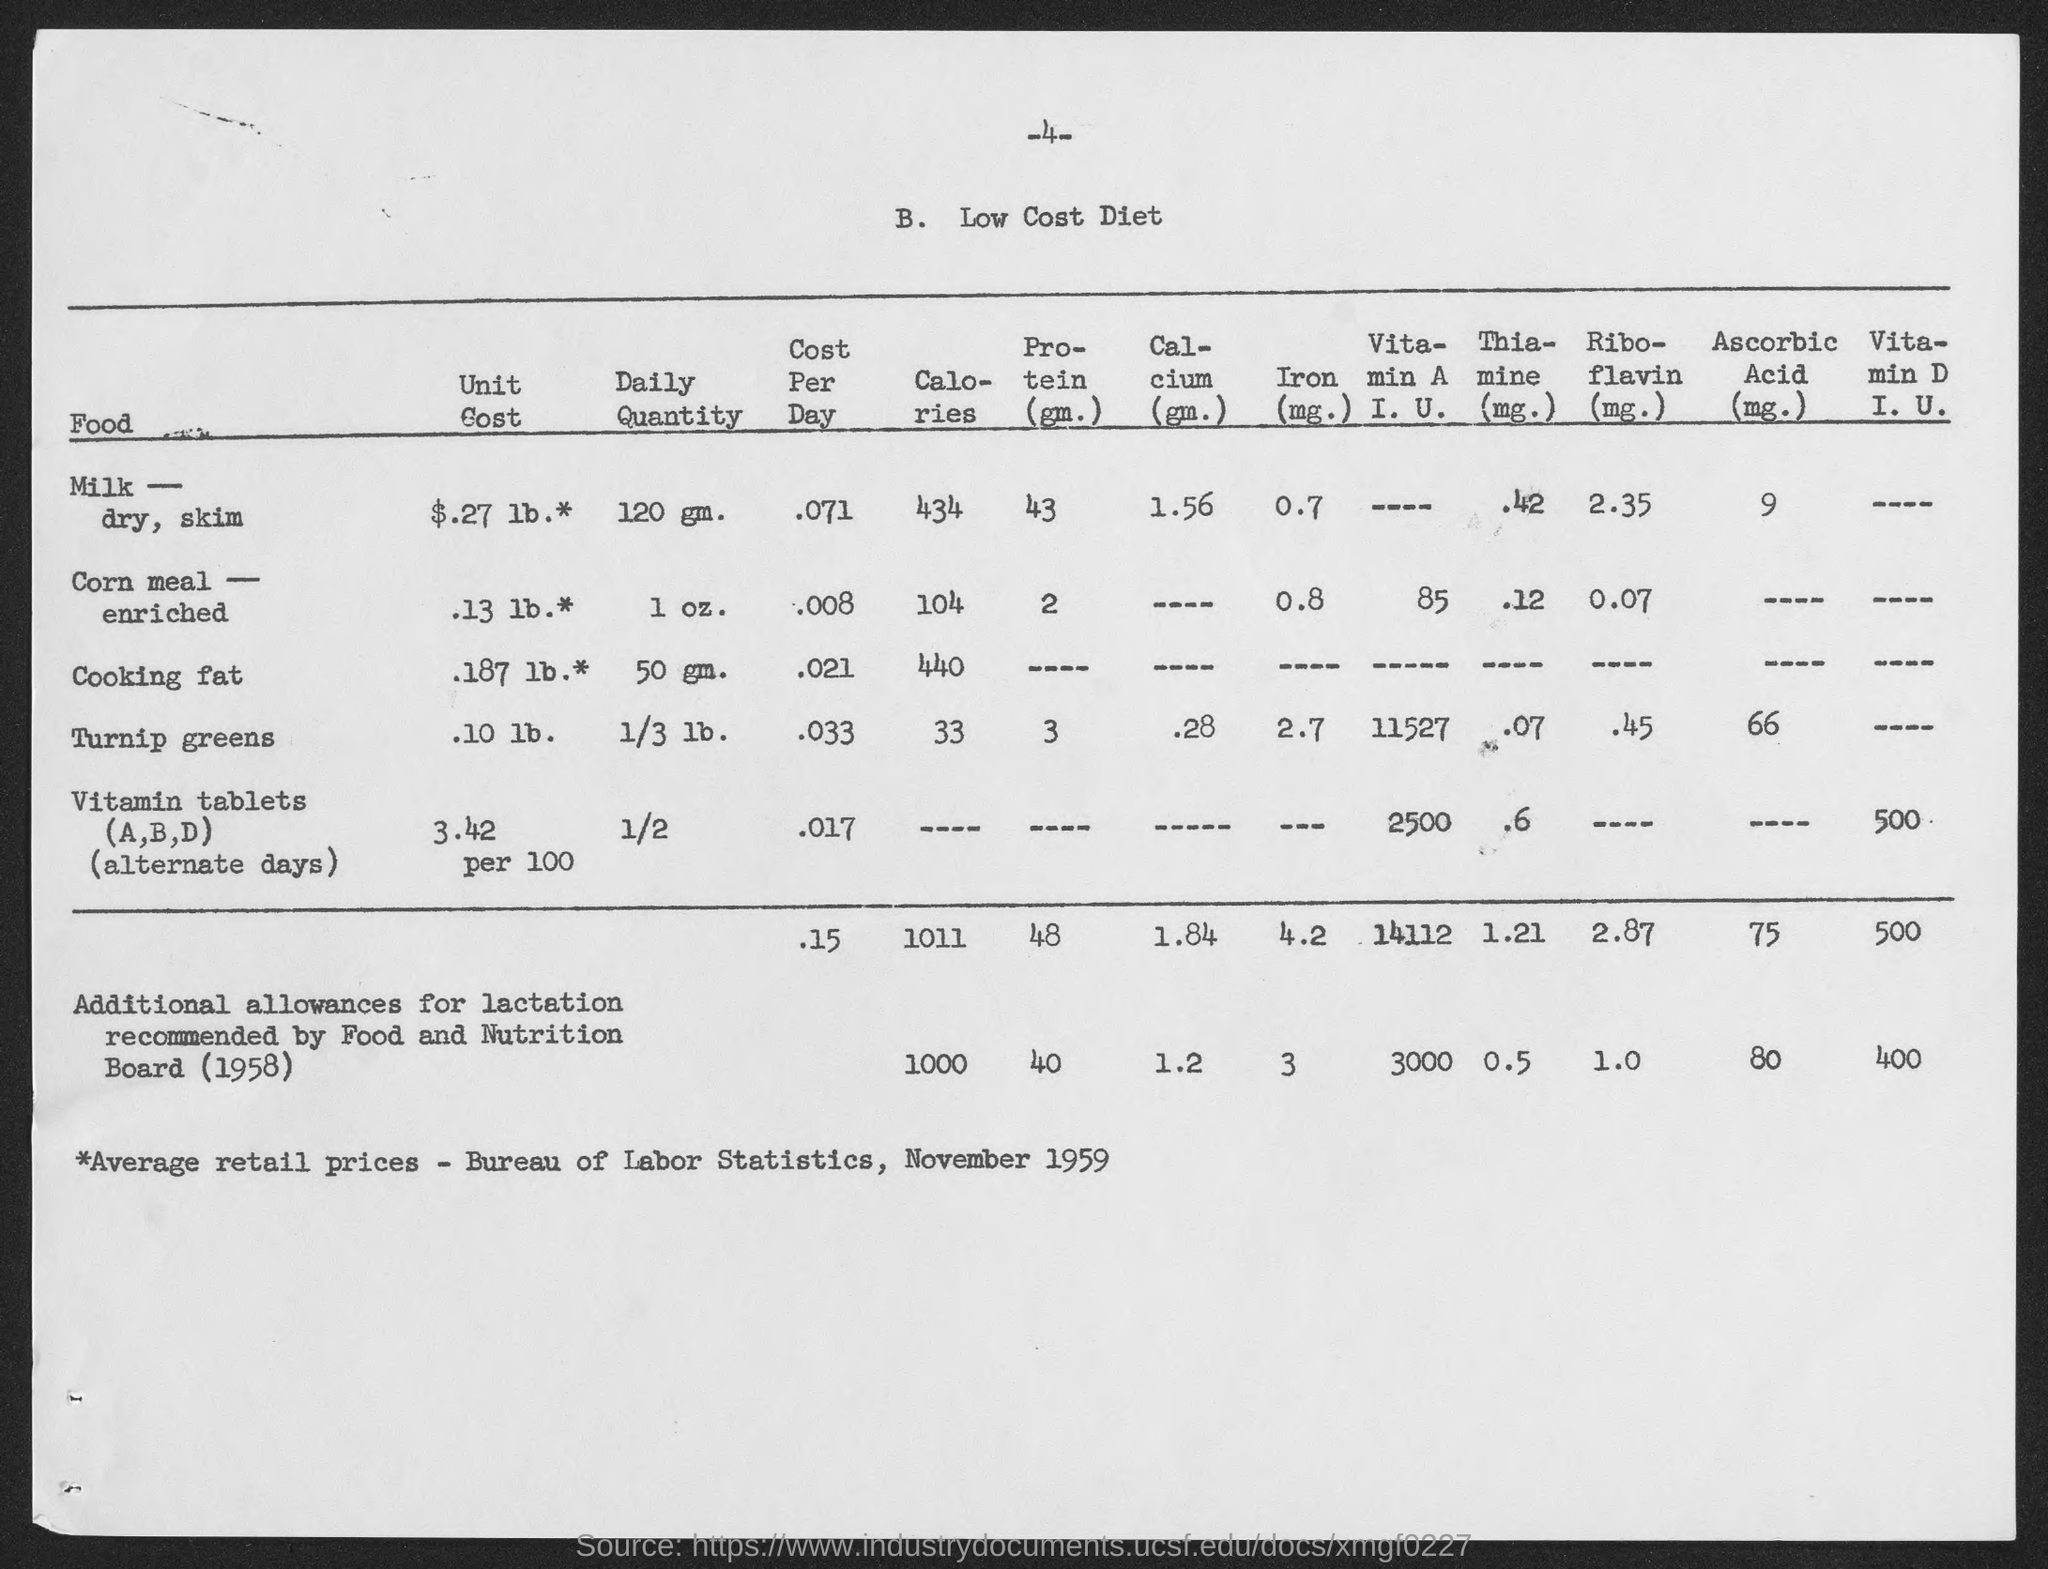Highlight a few significant elements in this photo. The daily amount of milk-dry, skin that is recommended is 120 grams. The recommended daily serving of turnip greens is 1/3 lb, which provides a significant amount of essential nutrients and vitamins. The cost per day for milk-dry, skin is approximately $0.071. The cost of turnip greens per day is approximately .033. The cost of corn meal-enriched is approximately $0.008 per day. 